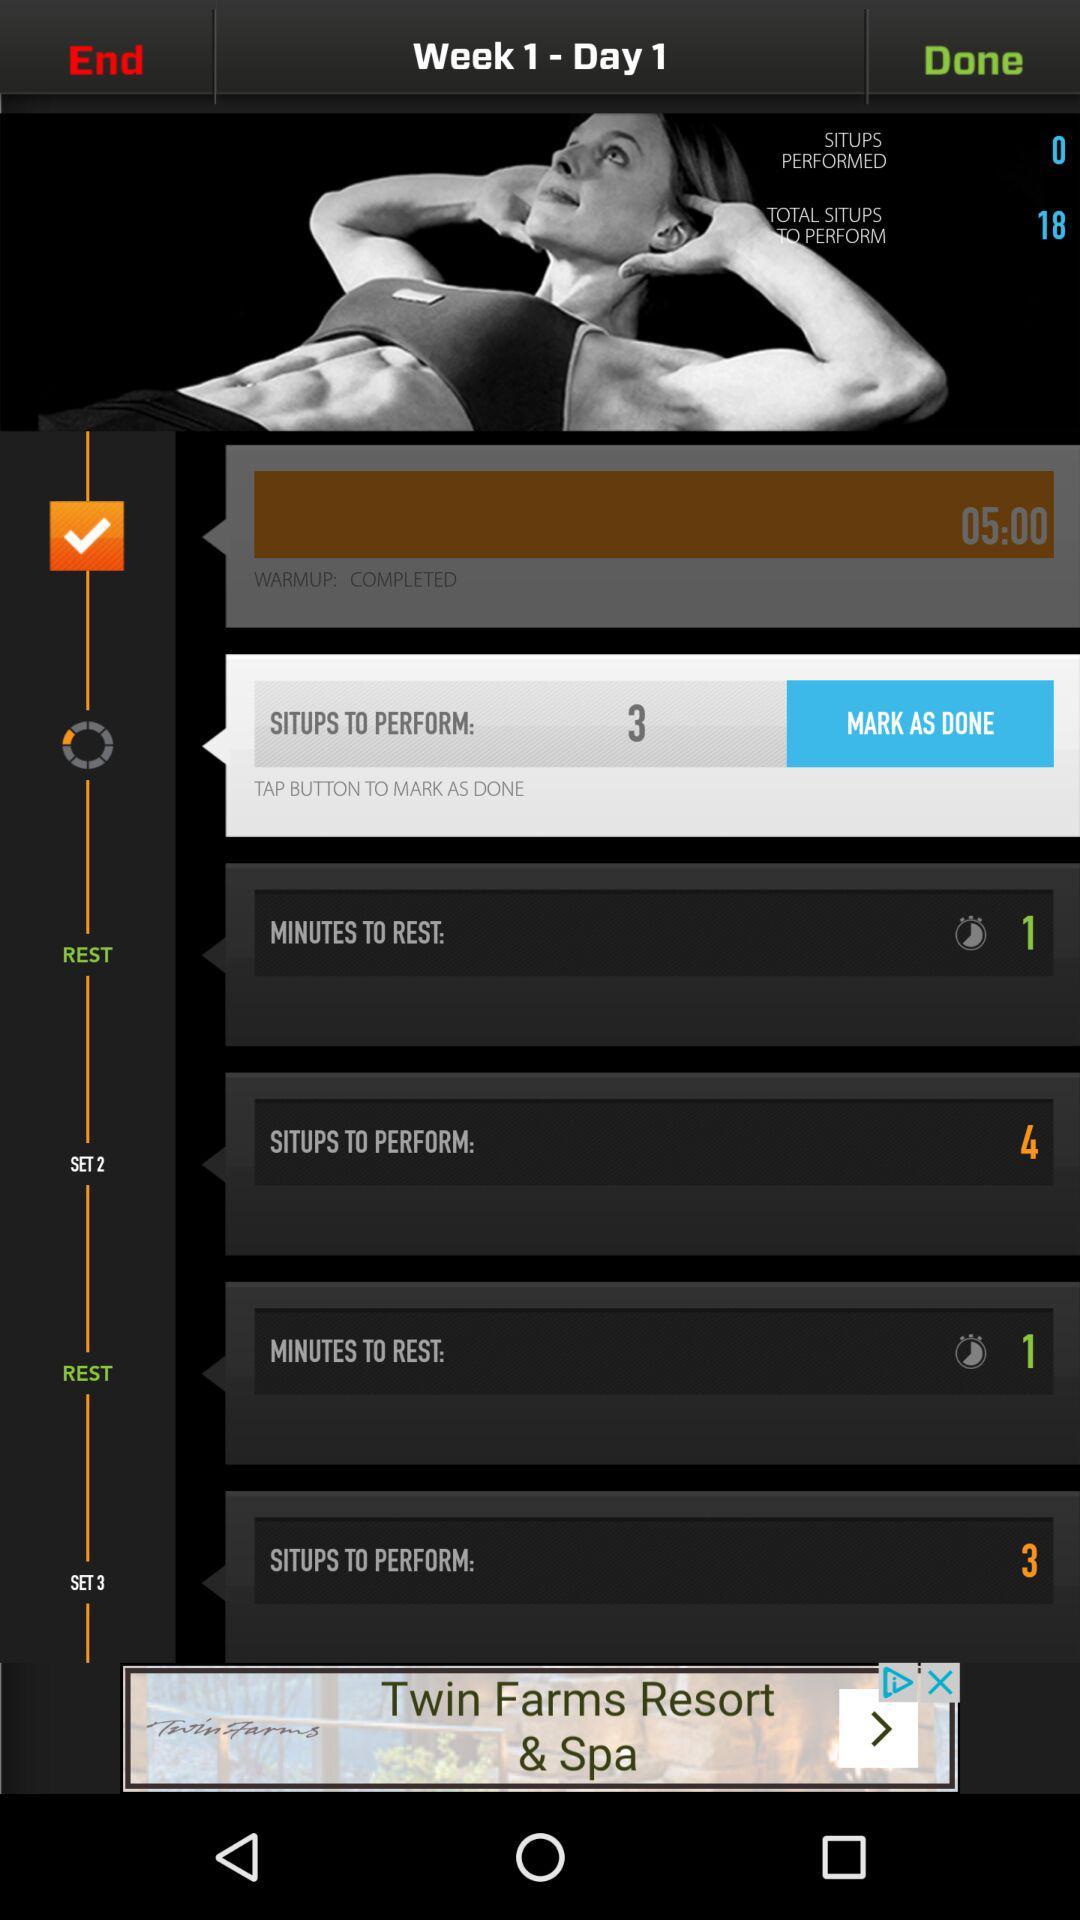How many situps have been performed? There are 3 situps have been performed. 